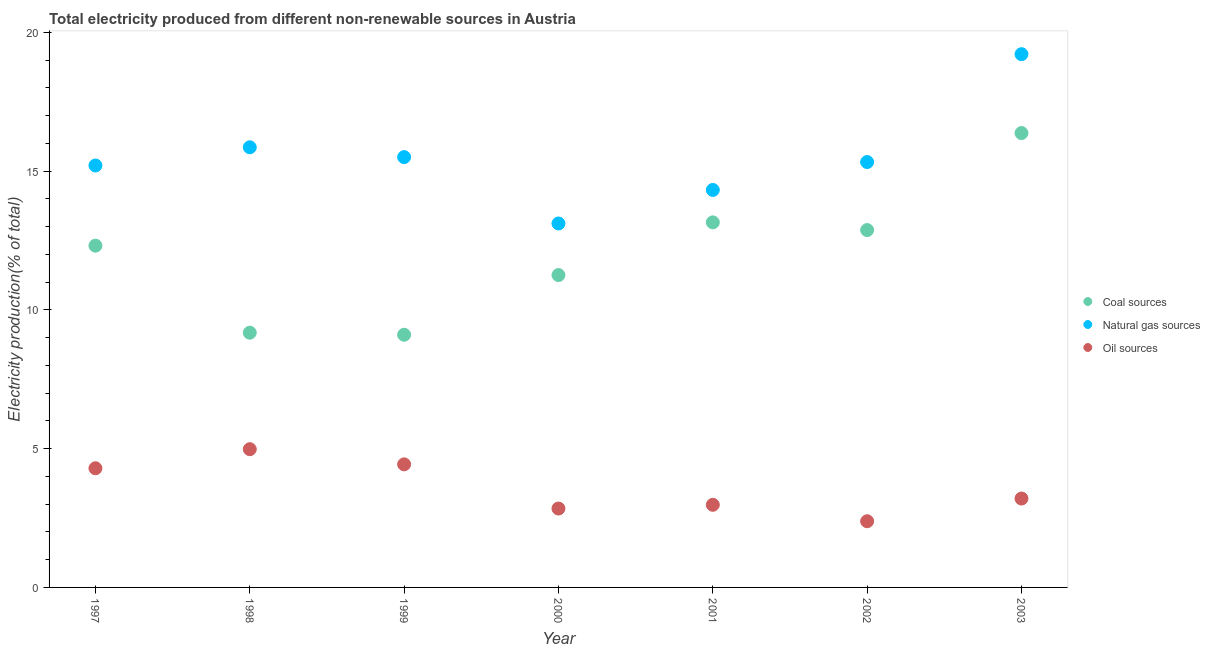What is the percentage of electricity produced by coal in 1998?
Give a very brief answer. 9.18. Across all years, what is the maximum percentage of electricity produced by oil sources?
Provide a short and direct response. 4.98. Across all years, what is the minimum percentage of electricity produced by oil sources?
Provide a short and direct response. 2.39. What is the total percentage of electricity produced by natural gas in the graph?
Make the answer very short. 108.55. What is the difference between the percentage of electricity produced by natural gas in 1999 and that in 2001?
Ensure brevity in your answer.  1.18. What is the difference between the percentage of electricity produced by oil sources in 2001 and the percentage of electricity produced by natural gas in 1999?
Offer a very short reply. -12.53. What is the average percentage of electricity produced by coal per year?
Make the answer very short. 12.04. In the year 1999, what is the difference between the percentage of electricity produced by natural gas and percentage of electricity produced by coal?
Your answer should be very brief. 6.4. In how many years, is the percentage of electricity produced by coal greater than 6 %?
Your answer should be compact. 7. What is the ratio of the percentage of electricity produced by oil sources in 2000 to that in 2002?
Offer a very short reply. 1.19. Is the difference between the percentage of electricity produced by oil sources in 1999 and 2002 greater than the difference between the percentage of electricity produced by natural gas in 1999 and 2002?
Provide a succinct answer. Yes. What is the difference between the highest and the second highest percentage of electricity produced by natural gas?
Your answer should be compact. 3.36. What is the difference between the highest and the lowest percentage of electricity produced by coal?
Offer a terse response. 7.27. Is the percentage of electricity produced by oil sources strictly greater than the percentage of electricity produced by coal over the years?
Keep it short and to the point. No. Is the percentage of electricity produced by natural gas strictly less than the percentage of electricity produced by coal over the years?
Ensure brevity in your answer.  No. How many dotlines are there?
Offer a very short reply. 3. What is the difference between two consecutive major ticks on the Y-axis?
Provide a succinct answer. 5. Are the values on the major ticks of Y-axis written in scientific E-notation?
Your answer should be very brief. No. Does the graph contain grids?
Ensure brevity in your answer.  No. How many legend labels are there?
Provide a succinct answer. 3. What is the title of the graph?
Offer a terse response. Total electricity produced from different non-renewable sources in Austria. Does "Ages 15-20" appear as one of the legend labels in the graph?
Ensure brevity in your answer.  No. What is the label or title of the Y-axis?
Your answer should be very brief. Electricity production(% of total). What is the Electricity production(% of total) of Coal sources in 1997?
Offer a terse response. 12.31. What is the Electricity production(% of total) in Natural gas sources in 1997?
Your response must be concise. 15.2. What is the Electricity production(% of total) of Oil sources in 1997?
Give a very brief answer. 4.29. What is the Electricity production(% of total) in Coal sources in 1998?
Offer a terse response. 9.18. What is the Electricity production(% of total) of Natural gas sources in 1998?
Keep it short and to the point. 15.86. What is the Electricity production(% of total) of Oil sources in 1998?
Ensure brevity in your answer.  4.98. What is the Electricity production(% of total) of Coal sources in 1999?
Your response must be concise. 9.1. What is the Electricity production(% of total) of Natural gas sources in 1999?
Offer a terse response. 15.51. What is the Electricity production(% of total) of Oil sources in 1999?
Keep it short and to the point. 4.43. What is the Electricity production(% of total) in Coal sources in 2000?
Offer a very short reply. 11.26. What is the Electricity production(% of total) in Natural gas sources in 2000?
Give a very brief answer. 13.11. What is the Electricity production(% of total) of Oil sources in 2000?
Give a very brief answer. 2.84. What is the Electricity production(% of total) in Coal sources in 2001?
Ensure brevity in your answer.  13.15. What is the Electricity production(% of total) in Natural gas sources in 2001?
Provide a short and direct response. 14.32. What is the Electricity production(% of total) in Oil sources in 2001?
Ensure brevity in your answer.  2.98. What is the Electricity production(% of total) in Coal sources in 2002?
Keep it short and to the point. 12.88. What is the Electricity production(% of total) of Natural gas sources in 2002?
Offer a very short reply. 15.33. What is the Electricity production(% of total) in Oil sources in 2002?
Provide a short and direct response. 2.39. What is the Electricity production(% of total) of Coal sources in 2003?
Give a very brief answer. 16.37. What is the Electricity production(% of total) of Natural gas sources in 2003?
Your answer should be compact. 19.21. What is the Electricity production(% of total) in Oil sources in 2003?
Make the answer very short. 3.2. Across all years, what is the maximum Electricity production(% of total) in Coal sources?
Offer a terse response. 16.37. Across all years, what is the maximum Electricity production(% of total) of Natural gas sources?
Your answer should be compact. 19.21. Across all years, what is the maximum Electricity production(% of total) in Oil sources?
Give a very brief answer. 4.98. Across all years, what is the minimum Electricity production(% of total) in Coal sources?
Make the answer very short. 9.1. Across all years, what is the minimum Electricity production(% of total) in Natural gas sources?
Ensure brevity in your answer.  13.11. Across all years, what is the minimum Electricity production(% of total) of Oil sources?
Offer a very short reply. 2.39. What is the total Electricity production(% of total) of Coal sources in the graph?
Ensure brevity in your answer.  84.26. What is the total Electricity production(% of total) of Natural gas sources in the graph?
Make the answer very short. 108.55. What is the total Electricity production(% of total) in Oil sources in the graph?
Your answer should be compact. 25.12. What is the difference between the Electricity production(% of total) in Coal sources in 1997 and that in 1998?
Your answer should be very brief. 3.13. What is the difference between the Electricity production(% of total) in Natural gas sources in 1997 and that in 1998?
Ensure brevity in your answer.  -0.66. What is the difference between the Electricity production(% of total) in Oil sources in 1997 and that in 1998?
Offer a terse response. -0.69. What is the difference between the Electricity production(% of total) of Coal sources in 1997 and that in 1999?
Ensure brevity in your answer.  3.21. What is the difference between the Electricity production(% of total) in Natural gas sources in 1997 and that in 1999?
Provide a succinct answer. -0.3. What is the difference between the Electricity production(% of total) of Oil sources in 1997 and that in 1999?
Your answer should be very brief. -0.14. What is the difference between the Electricity production(% of total) of Coal sources in 1997 and that in 2000?
Your response must be concise. 1.06. What is the difference between the Electricity production(% of total) of Natural gas sources in 1997 and that in 2000?
Your answer should be very brief. 2.09. What is the difference between the Electricity production(% of total) of Oil sources in 1997 and that in 2000?
Ensure brevity in your answer.  1.45. What is the difference between the Electricity production(% of total) in Coal sources in 1997 and that in 2001?
Provide a succinct answer. -0.84. What is the difference between the Electricity production(% of total) of Natural gas sources in 1997 and that in 2001?
Give a very brief answer. 0.88. What is the difference between the Electricity production(% of total) in Oil sources in 1997 and that in 2001?
Make the answer very short. 1.32. What is the difference between the Electricity production(% of total) of Coal sources in 1997 and that in 2002?
Keep it short and to the point. -0.56. What is the difference between the Electricity production(% of total) of Natural gas sources in 1997 and that in 2002?
Provide a succinct answer. -0.12. What is the difference between the Electricity production(% of total) in Oil sources in 1997 and that in 2002?
Give a very brief answer. 1.91. What is the difference between the Electricity production(% of total) in Coal sources in 1997 and that in 2003?
Your response must be concise. -4.06. What is the difference between the Electricity production(% of total) of Natural gas sources in 1997 and that in 2003?
Keep it short and to the point. -4.01. What is the difference between the Electricity production(% of total) of Oil sources in 1997 and that in 2003?
Give a very brief answer. 1.09. What is the difference between the Electricity production(% of total) of Coal sources in 1998 and that in 1999?
Ensure brevity in your answer.  0.07. What is the difference between the Electricity production(% of total) of Natural gas sources in 1998 and that in 1999?
Your answer should be very brief. 0.35. What is the difference between the Electricity production(% of total) in Oil sources in 1998 and that in 1999?
Make the answer very short. 0.55. What is the difference between the Electricity production(% of total) in Coal sources in 1998 and that in 2000?
Give a very brief answer. -2.08. What is the difference between the Electricity production(% of total) of Natural gas sources in 1998 and that in 2000?
Provide a succinct answer. 2.75. What is the difference between the Electricity production(% of total) of Oil sources in 1998 and that in 2000?
Keep it short and to the point. 2.14. What is the difference between the Electricity production(% of total) of Coal sources in 1998 and that in 2001?
Your answer should be very brief. -3.98. What is the difference between the Electricity production(% of total) of Natural gas sources in 1998 and that in 2001?
Offer a terse response. 1.54. What is the difference between the Electricity production(% of total) of Oil sources in 1998 and that in 2001?
Keep it short and to the point. 2. What is the difference between the Electricity production(% of total) of Coal sources in 1998 and that in 2002?
Give a very brief answer. -3.7. What is the difference between the Electricity production(% of total) in Natural gas sources in 1998 and that in 2002?
Ensure brevity in your answer.  0.53. What is the difference between the Electricity production(% of total) of Oil sources in 1998 and that in 2002?
Provide a short and direct response. 2.6. What is the difference between the Electricity production(% of total) of Coal sources in 1998 and that in 2003?
Your answer should be very brief. -7.19. What is the difference between the Electricity production(% of total) of Natural gas sources in 1998 and that in 2003?
Make the answer very short. -3.35. What is the difference between the Electricity production(% of total) of Oil sources in 1998 and that in 2003?
Keep it short and to the point. 1.78. What is the difference between the Electricity production(% of total) of Coal sources in 1999 and that in 2000?
Give a very brief answer. -2.15. What is the difference between the Electricity production(% of total) of Natural gas sources in 1999 and that in 2000?
Your answer should be compact. 2.39. What is the difference between the Electricity production(% of total) of Oil sources in 1999 and that in 2000?
Keep it short and to the point. 1.59. What is the difference between the Electricity production(% of total) of Coal sources in 1999 and that in 2001?
Offer a terse response. -4.05. What is the difference between the Electricity production(% of total) of Natural gas sources in 1999 and that in 2001?
Offer a terse response. 1.18. What is the difference between the Electricity production(% of total) in Oil sources in 1999 and that in 2001?
Give a very brief answer. 1.46. What is the difference between the Electricity production(% of total) in Coal sources in 1999 and that in 2002?
Keep it short and to the point. -3.77. What is the difference between the Electricity production(% of total) in Natural gas sources in 1999 and that in 2002?
Offer a very short reply. 0.18. What is the difference between the Electricity production(% of total) in Oil sources in 1999 and that in 2002?
Your answer should be compact. 2.05. What is the difference between the Electricity production(% of total) in Coal sources in 1999 and that in 2003?
Offer a terse response. -7.27. What is the difference between the Electricity production(% of total) in Natural gas sources in 1999 and that in 2003?
Ensure brevity in your answer.  -3.71. What is the difference between the Electricity production(% of total) in Oil sources in 1999 and that in 2003?
Your answer should be very brief. 1.23. What is the difference between the Electricity production(% of total) in Coal sources in 2000 and that in 2001?
Provide a short and direct response. -1.9. What is the difference between the Electricity production(% of total) of Natural gas sources in 2000 and that in 2001?
Provide a succinct answer. -1.21. What is the difference between the Electricity production(% of total) of Oil sources in 2000 and that in 2001?
Make the answer very short. -0.13. What is the difference between the Electricity production(% of total) of Coal sources in 2000 and that in 2002?
Give a very brief answer. -1.62. What is the difference between the Electricity production(% of total) in Natural gas sources in 2000 and that in 2002?
Provide a short and direct response. -2.21. What is the difference between the Electricity production(% of total) in Oil sources in 2000 and that in 2002?
Your answer should be very brief. 0.46. What is the difference between the Electricity production(% of total) of Coal sources in 2000 and that in 2003?
Keep it short and to the point. -5.12. What is the difference between the Electricity production(% of total) in Natural gas sources in 2000 and that in 2003?
Ensure brevity in your answer.  -6.1. What is the difference between the Electricity production(% of total) in Oil sources in 2000 and that in 2003?
Your response must be concise. -0.36. What is the difference between the Electricity production(% of total) in Coal sources in 2001 and that in 2002?
Your answer should be very brief. 0.28. What is the difference between the Electricity production(% of total) in Natural gas sources in 2001 and that in 2002?
Your answer should be very brief. -1.01. What is the difference between the Electricity production(% of total) of Oil sources in 2001 and that in 2002?
Give a very brief answer. 0.59. What is the difference between the Electricity production(% of total) of Coal sources in 2001 and that in 2003?
Give a very brief answer. -3.22. What is the difference between the Electricity production(% of total) of Natural gas sources in 2001 and that in 2003?
Offer a terse response. -4.89. What is the difference between the Electricity production(% of total) in Oil sources in 2001 and that in 2003?
Give a very brief answer. -0.23. What is the difference between the Electricity production(% of total) of Coal sources in 2002 and that in 2003?
Provide a short and direct response. -3.5. What is the difference between the Electricity production(% of total) in Natural gas sources in 2002 and that in 2003?
Make the answer very short. -3.89. What is the difference between the Electricity production(% of total) of Oil sources in 2002 and that in 2003?
Offer a very short reply. -0.82. What is the difference between the Electricity production(% of total) of Coal sources in 1997 and the Electricity production(% of total) of Natural gas sources in 1998?
Offer a terse response. -3.55. What is the difference between the Electricity production(% of total) of Coal sources in 1997 and the Electricity production(% of total) of Oil sources in 1998?
Keep it short and to the point. 7.33. What is the difference between the Electricity production(% of total) in Natural gas sources in 1997 and the Electricity production(% of total) in Oil sources in 1998?
Offer a very short reply. 10.22. What is the difference between the Electricity production(% of total) in Coal sources in 1997 and the Electricity production(% of total) in Natural gas sources in 1999?
Offer a terse response. -3.19. What is the difference between the Electricity production(% of total) of Coal sources in 1997 and the Electricity production(% of total) of Oil sources in 1999?
Keep it short and to the point. 7.88. What is the difference between the Electricity production(% of total) in Natural gas sources in 1997 and the Electricity production(% of total) in Oil sources in 1999?
Your response must be concise. 10.77. What is the difference between the Electricity production(% of total) in Coal sources in 1997 and the Electricity production(% of total) in Natural gas sources in 2000?
Give a very brief answer. -0.8. What is the difference between the Electricity production(% of total) in Coal sources in 1997 and the Electricity production(% of total) in Oil sources in 2000?
Keep it short and to the point. 9.47. What is the difference between the Electricity production(% of total) in Natural gas sources in 1997 and the Electricity production(% of total) in Oil sources in 2000?
Offer a very short reply. 12.36. What is the difference between the Electricity production(% of total) in Coal sources in 1997 and the Electricity production(% of total) in Natural gas sources in 2001?
Offer a terse response. -2.01. What is the difference between the Electricity production(% of total) of Coal sources in 1997 and the Electricity production(% of total) of Oil sources in 2001?
Your answer should be very brief. 9.34. What is the difference between the Electricity production(% of total) of Natural gas sources in 1997 and the Electricity production(% of total) of Oil sources in 2001?
Ensure brevity in your answer.  12.23. What is the difference between the Electricity production(% of total) of Coal sources in 1997 and the Electricity production(% of total) of Natural gas sources in 2002?
Provide a succinct answer. -3.01. What is the difference between the Electricity production(% of total) of Coal sources in 1997 and the Electricity production(% of total) of Oil sources in 2002?
Provide a succinct answer. 9.93. What is the difference between the Electricity production(% of total) of Natural gas sources in 1997 and the Electricity production(% of total) of Oil sources in 2002?
Your answer should be compact. 12.82. What is the difference between the Electricity production(% of total) in Coal sources in 1997 and the Electricity production(% of total) in Natural gas sources in 2003?
Provide a short and direct response. -6.9. What is the difference between the Electricity production(% of total) in Coal sources in 1997 and the Electricity production(% of total) in Oil sources in 2003?
Keep it short and to the point. 9.11. What is the difference between the Electricity production(% of total) of Natural gas sources in 1997 and the Electricity production(% of total) of Oil sources in 2003?
Your response must be concise. 12. What is the difference between the Electricity production(% of total) of Coal sources in 1998 and the Electricity production(% of total) of Natural gas sources in 1999?
Your answer should be compact. -6.33. What is the difference between the Electricity production(% of total) of Coal sources in 1998 and the Electricity production(% of total) of Oil sources in 1999?
Your answer should be very brief. 4.74. What is the difference between the Electricity production(% of total) of Natural gas sources in 1998 and the Electricity production(% of total) of Oil sources in 1999?
Keep it short and to the point. 11.42. What is the difference between the Electricity production(% of total) of Coal sources in 1998 and the Electricity production(% of total) of Natural gas sources in 2000?
Offer a terse response. -3.94. What is the difference between the Electricity production(% of total) of Coal sources in 1998 and the Electricity production(% of total) of Oil sources in 2000?
Provide a short and direct response. 6.34. What is the difference between the Electricity production(% of total) in Natural gas sources in 1998 and the Electricity production(% of total) in Oil sources in 2000?
Provide a succinct answer. 13.02. What is the difference between the Electricity production(% of total) in Coal sources in 1998 and the Electricity production(% of total) in Natural gas sources in 2001?
Make the answer very short. -5.14. What is the difference between the Electricity production(% of total) in Coal sources in 1998 and the Electricity production(% of total) in Oil sources in 2001?
Make the answer very short. 6.2. What is the difference between the Electricity production(% of total) in Natural gas sources in 1998 and the Electricity production(% of total) in Oil sources in 2001?
Your answer should be compact. 12.88. What is the difference between the Electricity production(% of total) of Coal sources in 1998 and the Electricity production(% of total) of Natural gas sources in 2002?
Provide a short and direct response. -6.15. What is the difference between the Electricity production(% of total) in Coal sources in 1998 and the Electricity production(% of total) in Oil sources in 2002?
Keep it short and to the point. 6.79. What is the difference between the Electricity production(% of total) in Natural gas sources in 1998 and the Electricity production(% of total) in Oil sources in 2002?
Offer a terse response. 13.47. What is the difference between the Electricity production(% of total) in Coal sources in 1998 and the Electricity production(% of total) in Natural gas sources in 2003?
Your answer should be very brief. -10.04. What is the difference between the Electricity production(% of total) of Coal sources in 1998 and the Electricity production(% of total) of Oil sources in 2003?
Provide a succinct answer. 5.98. What is the difference between the Electricity production(% of total) in Natural gas sources in 1998 and the Electricity production(% of total) in Oil sources in 2003?
Provide a succinct answer. 12.66. What is the difference between the Electricity production(% of total) in Coal sources in 1999 and the Electricity production(% of total) in Natural gas sources in 2000?
Give a very brief answer. -4.01. What is the difference between the Electricity production(% of total) in Coal sources in 1999 and the Electricity production(% of total) in Oil sources in 2000?
Provide a succinct answer. 6.26. What is the difference between the Electricity production(% of total) in Natural gas sources in 1999 and the Electricity production(% of total) in Oil sources in 2000?
Offer a very short reply. 12.66. What is the difference between the Electricity production(% of total) of Coal sources in 1999 and the Electricity production(% of total) of Natural gas sources in 2001?
Keep it short and to the point. -5.22. What is the difference between the Electricity production(% of total) of Coal sources in 1999 and the Electricity production(% of total) of Oil sources in 2001?
Keep it short and to the point. 6.13. What is the difference between the Electricity production(% of total) in Natural gas sources in 1999 and the Electricity production(% of total) in Oil sources in 2001?
Provide a succinct answer. 12.53. What is the difference between the Electricity production(% of total) of Coal sources in 1999 and the Electricity production(% of total) of Natural gas sources in 2002?
Ensure brevity in your answer.  -6.22. What is the difference between the Electricity production(% of total) of Coal sources in 1999 and the Electricity production(% of total) of Oil sources in 2002?
Ensure brevity in your answer.  6.72. What is the difference between the Electricity production(% of total) in Natural gas sources in 1999 and the Electricity production(% of total) in Oil sources in 2002?
Provide a succinct answer. 13.12. What is the difference between the Electricity production(% of total) of Coal sources in 1999 and the Electricity production(% of total) of Natural gas sources in 2003?
Provide a short and direct response. -10.11. What is the difference between the Electricity production(% of total) of Coal sources in 1999 and the Electricity production(% of total) of Oil sources in 2003?
Your answer should be very brief. 5.9. What is the difference between the Electricity production(% of total) of Natural gas sources in 1999 and the Electricity production(% of total) of Oil sources in 2003?
Your answer should be compact. 12.3. What is the difference between the Electricity production(% of total) of Coal sources in 2000 and the Electricity production(% of total) of Natural gas sources in 2001?
Your answer should be compact. -3.07. What is the difference between the Electricity production(% of total) of Coal sources in 2000 and the Electricity production(% of total) of Oil sources in 2001?
Provide a succinct answer. 8.28. What is the difference between the Electricity production(% of total) in Natural gas sources in 2000 and the Electricity production(% of total) in Oil sources in 2001?
Your response must be concise. 10.14. What is the difference between the Electricity production(% of total) in Coal sources in 2000 and the Electricity production(% of total) in Natural gas sources in 2002?
Ensure brevity in your answer.  -4.07. What is the difference between the Electricity production(% of total) of Coal sources in 2000 and the Electricity production(% of total) of Oil sources in 2002?
Your answer should be very brief. 8.87. What is the difference between the Electricity production(% of total) in Natural gas sources in 2000 and the Electricity production(% of total) in Oil sources in 2002?
Offer a terse response. 10.73. What is the difference between the Electricity production(% of total) in Coal sources in 2000 and the Electricity production(% of total) in Natural gas sources in 2003?
Keep it short and to the point. -7.96. What is the difference between the Electricity production(% of total) of Coal sources in 2000 and the Electricity production(% of total) of Oil sources in 2003?
Offer a very short reply. 8.05. What is the difference between the Electricity production(% of total) of Natural gas sources in 2000 and the Electricity production(% of total) of Oil sources in 2003?
Offer a terse response. 9.91. What is the difference between the Electricity production(% of total) in Coal sources in 2001 and the Electricity production(% of total) in Natural gas sources in 2002?
Offer a very short reply. -2.17. What is the difference between the Electricity production(% of total) in Coal sources in 2001 and the Electricity production(% of total) in Oil sources in 2002?
Provide a short and direct response. 10.77. What is the difference between the Electricity production(% of total) in Natural gas sources in 2001 and the Electricity production(% of total) in Oil sources in 2002?
Give a very brief answer. 11.94. What is the difference between the Electricity production(% of total) of Coal sources in 2001 and the Electricity production(% of total) of Natural gas sources in 2003?
Give a very brief answer. -6.06. What is the difference between the Electricity production(% of total) in Coal sources in 2001 and the Electricity production(% of total) in Oil sources in 2003?
Offer a terse response. 9.95. What is the difference between the Electricity production(% of total) of Natural gas sources in 2001 and the Electricity production(% of total) of Oil sources in 2003?
Provide a short and direct response. 11.12. What is the difference between the Electricity production(% of total) of Coal sources in 2002 and the Electricity production(% of total) of Natural gas sources in 2003?
Give a very brief answer. -6.34. What is the difference between the Electricity production(% of total) of Coal sources in 2002 and the Electricity production(% of total) of Oil sources in 2003?
Provide a succinct answer. 9.67. What is the difference between the Electricity production(% of total) of Natural gas sources in 2002 and the Electricity production(% of total) of Oil sources in 2003?
Provide a short and direct response. 12.12. What is the average Electricity production(% of total) of Coal sources per year?
Give a very brief answer. 12.04. What is the average Electricity production(% of total) in Natural gas sources per year?
Offer a terse response. 15.51. What is the average Electricity production(% of total) in Oil sources per year?
Offer a terse response. 3.59. In the year 1997, what is the difference between the Electricity production(% of total) in Coal sources and Electricity production(% of total) in Natural gas sources?
Ensure brevity in your answer.  -2.89. In the year 1997, what is the difference between the Electricity production(% of total) in Coal sources and Electricity production(% of total) in Oil sources?
Your response must be concise. 8.02. In the year 1997, what is the difference between the Electricity production(% of total) in Natural gas sources and Electricity production(% of total) in Oil sources?
Offer a terse response. 10.91. In the year 1998, what is the difference between the Electricity production(% of total) in Coal sources and Electricity production(% of total) in Natural gas sources?
Provide a short and direct response. -6.68. In the year 1998, what is the difference between the Electricity production(% of total) in Coal sources and Electricity production(% of total) in Oil sources?
Ensure brevity in your answer.  4.2. In the year 1998, what is the difference between the Electricity production(% of total) of Natural gas sources and Electricity production(% of total) of Oil sources?
Make the answer very short. 10.88. In the year 1999, what is the difference between the Electricity production(% of total) in Coal sources and Electricity production(% of total) in Natural gas sources?
Provide a succinct answer. -6.4. In the year 1999, what is the difference between the Electricity production(% of total) of Coal sources and Electricity production(% of total) of Oil sources?
Provide a succinct answer. 4.67. In the year 1999, what is the difference between the Electricity production(% of total) in Natural gas sources and Electricity production(% of total) in Oil sources?
Offer a terse response. 11.07. In the year 2000, what is the difference between the Electricity production(% of total) in Coal sources and Electricity production(% of total) in Natural gas sources?
Give a very brief answer. -1.86. In the year 2000, what is the difference between the Electricity production(% of total) in Coal sources and Electricity production(% of total) in Oil sources?
Ensure brevity in your answer.  8.41. In the year 2000, what is the difference between the Electricity production(% of total) in Natural gas sources and Electricity production(% of total) in Oil sources?
Offer a terse response. 10.27. In the year 2001, what is the difference between the Electricity production(% of total) in Coal sources and Electricity production(% of total) in Natural gas sources?
Your answer should be very brief. -1.17. In the year 2001, what is the difference between the Electricity production(% of total) in Coal sources and Electricity production(% of total) in Oil sources?
Keep it short and to the point. 10.18. In the year 2001, what is the difference between the Electricity production(% of total) of Natural gas sources and Electricity production(% of total) of Oil sources?
Give a very brief answer. 11.34. In the year 2002, what is the difference between the Electricity production(% of total) of Coal sources and Electricity production(% of total) of Natural gas sources?
Provide a short and direct response. -2.45. In the year 2002, what is the difference between the Electricity production(% of total) of Coal sources and Electricity production(% of total) of Oil sources?
Provide a short and direct response. 10.49. In the year 2002, what is the difference between the Electricity production(% of total) of Natural gas sources and Electricity production(% of total) of Oil sources?
Make the answer very short. 12.94. In the year 2003, what is the difference between the Electricity production(% of total) of Coal sources and Electricity production(% of total) of Natural gas sources?
Provide a short and direct response. -2.84. In the year 2003, what is the difference between the Electricity production(% of total) of Coal sources and Electricity production(% of total) of Oil sources?
Give a very brief answer. 13.17. In the year 2003, what is the difference between the Electricity production(% of total) in Natural gas sources and Electricity production(% of total) in Oil sources?
Your response must be concise. 16.01. What is the ratio of the Electricity production(% of total) of Coal sources in 1997 to that in 1998?
Give a very brief answer. 1.34. What is the ratio of the Electricity production(% of total) of Natural gas sources in 1997 to that in 1998?
Make the answer very short. 0.96. What is the ratio of the Electricity production(% of total) of Oil sources in 1997 to that in 1998?
Give a very brief answer. 0.86. What is the ratio of the Electricity production(% of total) in Coal sources in 1997 to that in 1999?
Keep it short and to the point. 1.35. What is the ratio of the Electricity production(% of total) of Natural gas sources in 1997 to that in 1999?
Provide a succinct answer. 0.98. What is the ratio of the Electricity production(% of total) in Oil sources in 1997 to that in 1999?
Make the answer very short. 0.97. What is the ratio of the Electricity production(% of total) of Coal sources in 1997 to that in 2000?
Keep it short and to the point. 1.09. What is the ratio of the Electricity production(% of total) in Natural gas sources in 1997 to that in 2000?
Ensure brevity in your answer.  1.16. What is the ratio of the Electricity production(% of total) of Oil sources in 1997 to that in 2000?
Your response must be concise. 1.51. What is the ratio of the Electricity production(% of total) in Coal sources in 1997 to that in 2001?
Your response must be concise. 0.94. What is the ratio of the Electricity production(% of total) of Natural gas sources in 1997 to that in 2001?
Provide a short and direct response. 1.06. What is the ratio of the Electricity production(% of total) in Oil sources in 1997 to that in 2001?
Provide a succinct answer. 1.44. What is the ratio of the Electricity production(% of total) in Coal sources in 1997 to that in 2002?
Your response must be concise. 0.96. What is the ratio of the Electricity production(% of total) of Oil sources in 1997 to that in 2002?
Make the answer very short. 1.8. What is the ratio of the Electricity production(% of total) of Coal sources in 1997 to that in 2003?
Provide a succinct answer. 0.75. What is the ratio of the Electricity production(% of total) of Natural gas sources in 1997 to that in 2003?
Your answer should be compact. 0.79. What is the ratio of the Electricity production(% of total) of Oil sources in 1997 to that in 2003?
Your answer should be compact. 1.34. What is the ratio of the Electricity production(% of total) in Coal sources in 1998 to that in 1999?
Your answer should be very brief. 1.01. What is the ratio of the Electricity production(% of total) in Natural gas sources in 1998 to that in 1999?
Give a very brief answer. 1.02. What is the ratio of the Electricity production(% of total) of Oil sources in 1998 to that in 1999?
Offer a very short reply. 1.12. What is the ratio of the Electricity production(% of total) in Coal sources in 1998 to that in 2000?
Give a very brief answer. 0.82. What is the ratio of the Electricity production(% of total) in Natural gas sources in 1998 to that in 2000?
Ensure brevity in your answer.  1.21. What is the ratio of the Electricity production(% of total) in Oil sources in 1998 to that in 2000?
Give a very brief answer. 1.75. What is the ratio of the Electricity production(% of total) of Coal sources in 1998 to that in 2001?
Provide a short and direct response. 0.7. What is the ratio of the Electricity production(% of total) in Natural gas sources in 1998 to that in 2001?
Offer a terse response. 1.11. What is the ratio of the Electricity production(% of total) in Oil sources in 1998 to that in 2001?
Your answer should be very brief. 1.67. What is the ratio of the Electricity production(% of total) in Coal sources in 1998 to that in 2002?
Provide a succinct answer. 0.71. What is the ratio of the Electricity production(% of total) in Natural gas sources in 1998 to that in 2002?
Offer a very short reply. 1.03. What is the ratio of the Electricity production(% of total) in Oil sources in 1998 to that in 2002?
Provide a short and direct response. 2.09. What is the ratio of the Electricity production(% of total) in Coal sources in 1998 to that in 2003?
Make the answer very short. 0.56. What is the ratio of the Electricity production(% of total) of Natural gas sources in 1998 to that in 2003?
Keep it short and to the point. 0.83. What is the ratio of the Electricity production(% of total) of Oil sources in 1998 to that in 2003?
Give a very brief answer. 1.55. What is the ratio of the Electricity production(% of total) of Coal sources in 1999 to that in 2000?
Make the answer very short. 0.81. What is the ratio of the Electricity production(% of total) of Natural gas sources in 1999 to that in 2000?
Keep it short and to the point. 1.18. What is the ratio of the Electricity production(% of total) of Oil sources in 1999 to that in 2000?
Offer a very short reply. 1.56. What is the ratio of the Electricity production(% of total) of Coal sources in 1999 to that in 2001?
Make the answer very short. 0.69. What is the ratio of the Electricity production(% of total) of Natural gas sources in 1999 to that in 2001?
Ensure brevity in your answer.  1.08. What is the ratio of the Electricity production(% of total) of Oil sources in 1999 to that in 2001?
Offer a very short reply. 1.49. What is the ratio of the Electricity production(% of total) in Coal sources in 1999 to that in 2002?
Your response must be concise. 0.71. What is the ratio of the Electricity production(% of total) in Natural gas sources in 1999 to that in 2002?
Ensure brevity in your answer.  1.01. What is the ratio of the Electricity production(% of total) of Oil sources in 1999 to that in 2002?
Your response must be concise. 1.86. What is the ratio of the Electricity production(% of total) in Coal sources in 1999 to that in 2003?
Offer a terse response. 0.56. What is the ratio of the Electricity production(% of total) in Natural gas sources in 1999 to that in 2003?
Your response must be concise. 0.81. What is the ratio of the Electricity production(% of total) of Oil sources in 1999 to that in 2003?
Offer a very short reply. 1.38. What is the ratio of the Electricity production(% of total) in Coal sources in 2000 to that in 2001?
Keep it short and to the point. 0.86. What is the ratio of the Electricity production(% of total) in Natural gas sources in 2000 to that in 2001?
Provide a short and direct response. 0.92. What is the ratio of the Electricity production(% of total) of Oil sources in 2000 to that in 2001?
Offer a terse response. 0.95. What is the ratio of the Electricity production(% of total) in Coal sources in 2000 to that in 2002?
Your answer should be compact. 0.87. What is the ratio of the Electricity production(% of total) in Natural gas sources in 2000 to that in 2002?
Keep it short and to the point. 0.86. What is the ratio of the Electricity production(% of total) of Oil sources in 2000 to that in 2002?
Your answer should be very brief. 1.19. What is the ratio of the Electricity production(% of total) of Coal sources in 2000 to that in 2003?
Provide a succinct answer. 0.69. What is the ratio of the Electricity production(% of total) of Natural gas sources in 2000 to that in 2003?
Provide a succinct answer. 0.68. What is the ratio of the Electricity production(% of total) of Oil sources in 2000 to that in 2003?
Keep it short and to the point. 0.89. What is the ratio of the Electricity production(% of total) in Coal sources in 2001 to that in 2002?
Your answer should be compact. 1.02. What is the ratio of the Electricity production(% of total) in Natural gas sources in 2001 to that in 2002?
Your response must be concise. 0.93. What is the ratio of the Electricity production(% of total) of Oil sources in 2001 to that in 2002?
Your answer should be compact. 1.25. What is the ratio of the Electricity production(% of total) of Coal sources in 2001 to that in 2003?
Your response must be concise. 0.8. What is the ratio of the Electricity production(% of total) in Natural gas sources in 2001 to that in 2003?
Offer a very short reply. 0.75. What is the ratio of the Electricity production(% of total) in Oil sources in 2001 to that in 2003?
Provide a short and direct response. 0.93. What is the ratio of the Electricity production(% of total) in Coal sources in 2002 to that in 2003?
Offer a terse response. 0.79. What is the ratio of the Electricity production(% of total) in Natural gas sources in 2002 to that in 2003?
Provide a succinct answer. 0.8. What is the ratio of the Electricity production(% of total) of Oil sources in 2002 to that in 2003?
Give a very brief answer. 0.74. What is the difference between the highest and the second highest Electricity production(% of total) of Coal sources?
Ensure brevity in your answer.  3.22. What is the difference between the highest and the second highest Electricity production(% of total) of Natural gas sources?
Your response must be concise. 3.35. What is the difference between the highest and the second highest Electricity production(% of total) of Oil sources?
Offer a very short reply. 0.55. What is the difference between the highest and the lowest Electricity production(% of total) in Coal sources?
Provide a short and direct response. 7.27. What is the difference between the highest and the lowest Electricity production(% of total) of Natural gas sources?
Offer a very short reply. 6.1. What is the difference between the highest and the lowest Electricity production(% of total) in Oil sources?
Ensure brevity in your answer.  2.6. 